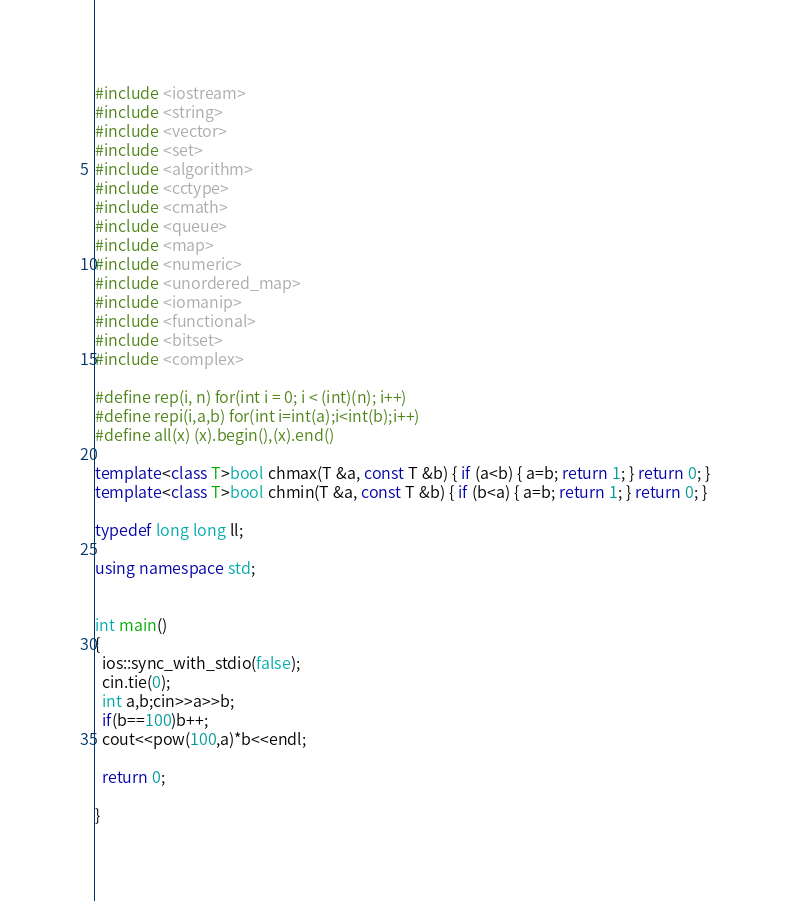<code> <loc_0><loc_0><loc_500><loc_500><_C++_>#include <iostream>
#include <string>
#include <vector>
#include <set>
#include <algorithm>
#include <cctype>
#include <cmath>
#include <queue>
#include <map>
#include <numeric>
#include <unordered_map>
#include <iomanip>
#include <functional>
#include <bitset>
#include <complex>

#define rep(i, n) for(int i = 0; i < (int)(n); i++)
#define repi(i,a,b) for(int i=int(a);i<int(b);i++)
#define all(x) (x).begin(),(x).end()

template<class T>bool chmax(T &a, const T &b) { if (a<b) { a=b; return 1; } return 0; }
template<class T>bool chmin(T &a, const T &b) { if (b<a) { a=b; return 1; } return 0; }

typedef long long ll;

using namespace std;


int main()
{
  ios::sync_with_stdio(false);
  cin.tie(0);
  int a,b;cin>>a>>b;
  if(b==100)b++;
  cout<<pow(100,a)*b<<endl;

  return 0;

}
</code> 